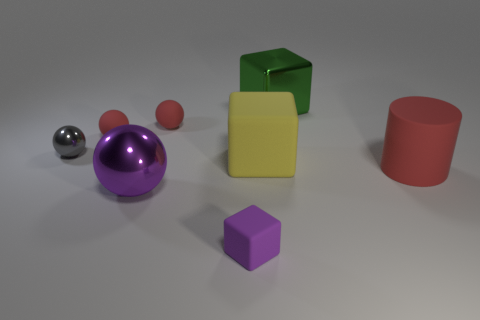Subtract all yellow spheres. Subtract all yellow cylinders. How many spheres are left? 4 Add 2 large red rubber cylinders. How many objects exist? 10 Subtract all cubes. How many objects are left? 5 Add 7 matte blocks. How many matte blocks exist? 9 Subtract 0 cyan cylinders. How many objects are left? 8 Subtract all large rubber objects. Subtract all large yellow cubes. How many objects are left? 5 Add 4 large purple metallic balls. How many large purple metallic balls are left? 5 